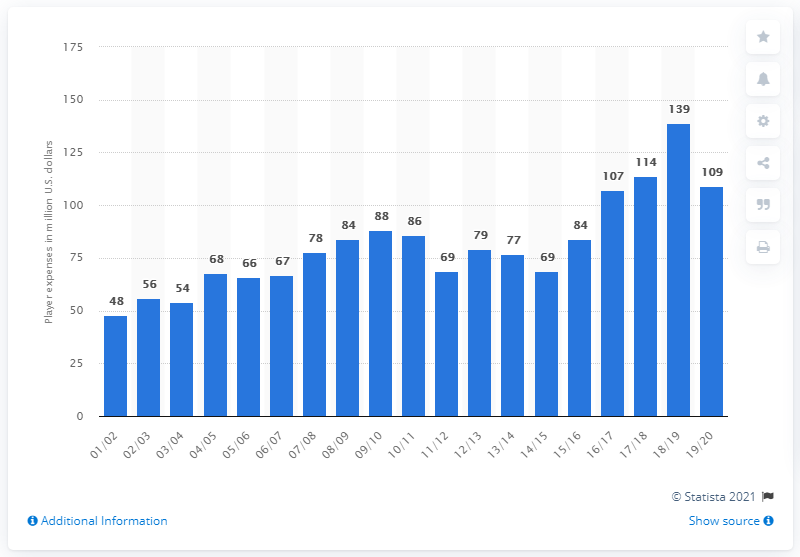Give some essential details in this illustration. The player salary of the Boston Celtics for the 2019/20 season was $109 million. 